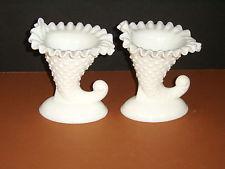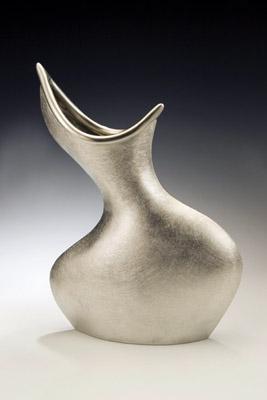The first image is the image on the left, the second image is the image on the right. For the images displayed, is the sentence "Two vases in one image are a matched set, while a single vase in the second image is solid white on an oval base." factually correct? Answer yes or no. No. The first image is the image on the left, the second image is the image on the right. Assess this claim about the two images: "An image shows a matched pair of white vases.". Correct or not? Answer yes or no. Yes. 